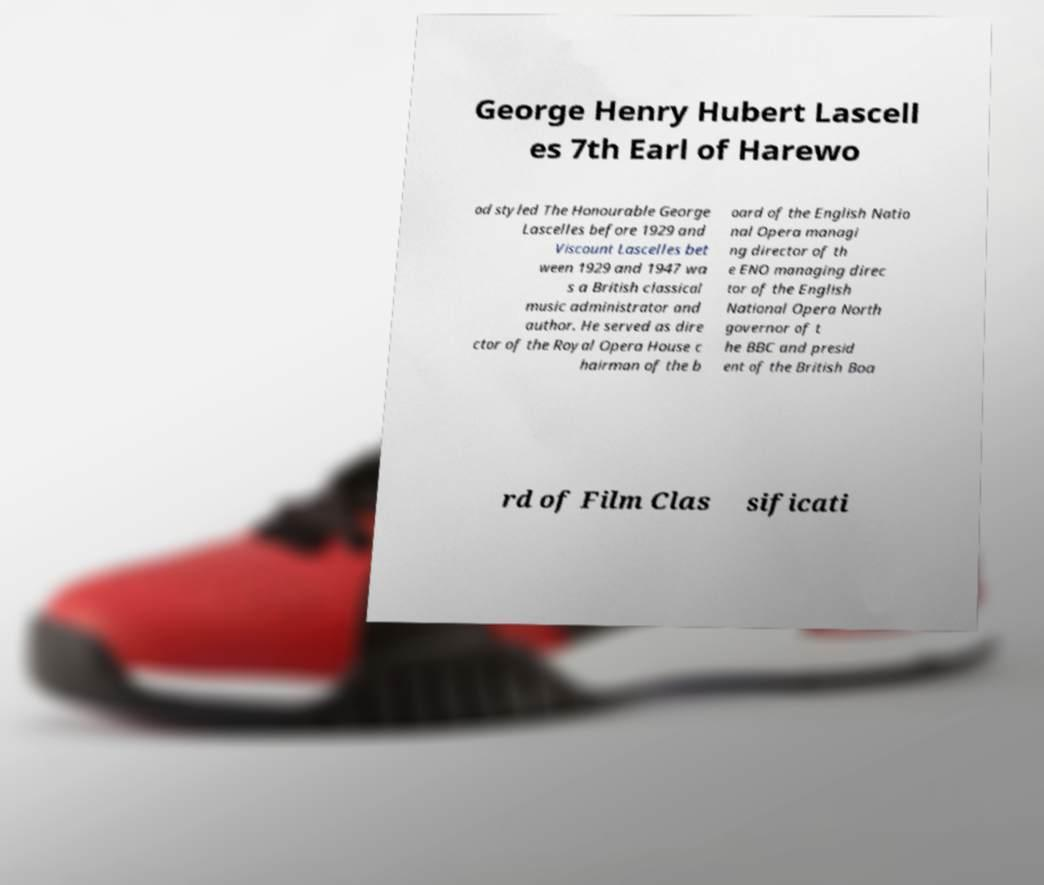Could you assist in decoding the text presented in this image and type it out clearly? George Henry Hubert Lascell es 7th Earl of Harewo od styled The Honourable George Lascelles before 1929 and Viscount Lascelles bet ween 1929 and 1947 wa s a British classical music administrator and author. He served as dire ctor of the Royal Opera House c hairman of the b oard of the English Natio nal Opera managi ng director of th e ENO managing direc tor of the English National Opera North governor of t he BBC and presid ent of the British Boa rd of Film Clas sificati 